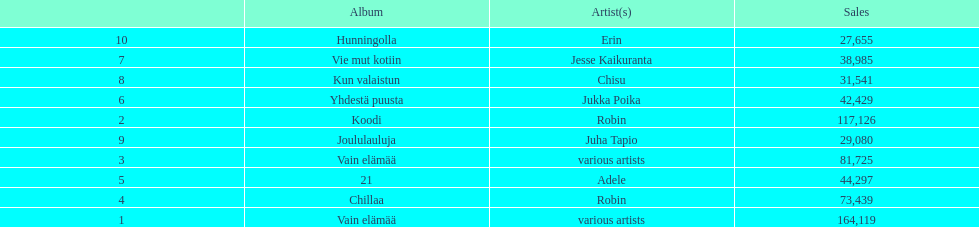Could you parse the entire table? {'header': ['', 'Album', 'Artist(s)', 'Sales'], 'rows': [['10', 'Hunningolla', 'Erin', '27,655'], ['7', 'Vie mut kotiin', 'Jesse Kaikuranta', '38,985'], ['8', 'Kun valaistun', 'Chisu', '31,541'], ['6', 'Yhdestä puusta', 'Jukka Poika', '42,429'], ['2', 'Koodi', 'Robin', '117,126'], ['9', 'Joululauluja', 'Juha Tapio', '29,080'], ['3', 'Vain elämää', 'various artists', '81,725'], ['5', '21', 'Adele', '44,297'], ['4', 'Chillaa', 'Robin', '73,439'], ['1', 'Vain elämää', 'various artists', '164,119']]} What is the total number of sales for the top 10 albums? 650396. 